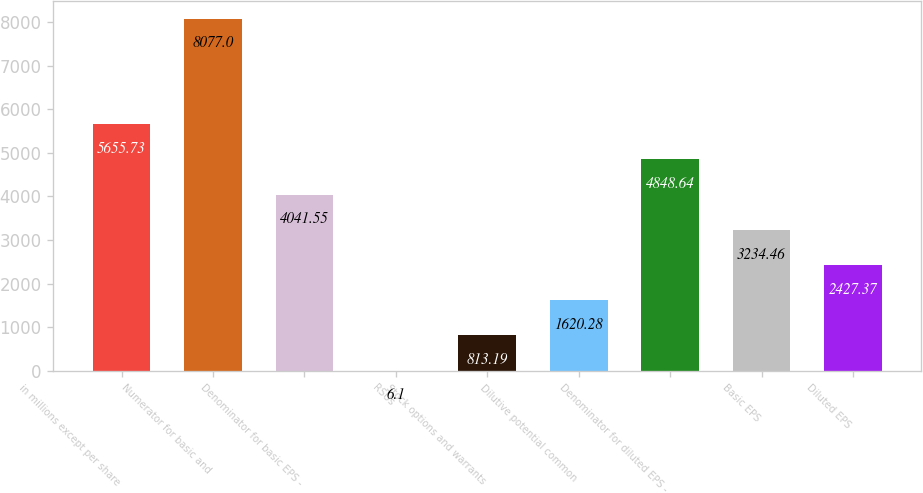<chart> <loc_0><loc_0><loc_500><loc_500><bar_chart><fcel>in millions except per share<fcel>Numerator for basic and<fcel>Denominator for basic EPS -<fcel>RSUs<fcel>Stock options and warrants<fcel>Dilutive potential common<fcel>Denominator for diluted EPS -<fcel>Basic EPS<fcel>Diluted EPS<nl><fcel>5655.73<fcel>8077<fcel>4041.55<fcel>6.1<fcel>813.19<fcel>1620.28<fcel>4848.64<fcel>3234.46<fcel>2427.37<nl></chart> 